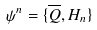Convert formula to latex. <formula><loc_0><loc_0><loc_500><loc_500>\psi ^ { n } = \{ \overline { Q } , H _ { n } \}</formula> 